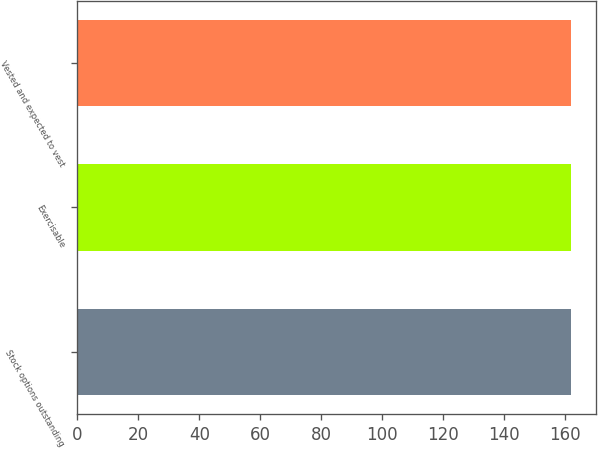<chart> <loc_0><loc_0><loc_500><loc_500><bar_chart><fcel>Stock options outstanding<fcel>Exercisable<fcel>Vested and expected to vest<nl><fcel>162<fcel>162.1<fcel>162.2<nl></chart> 